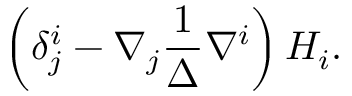<formula> <loc_0><loc_0><loc_500><loc_500>\left ( \delta _ { j } ^ { i } - \nabla _ { j } \frac { 1 } { \Delta } \nabla ^ { i } \right ) H _ { i } .</formula> 